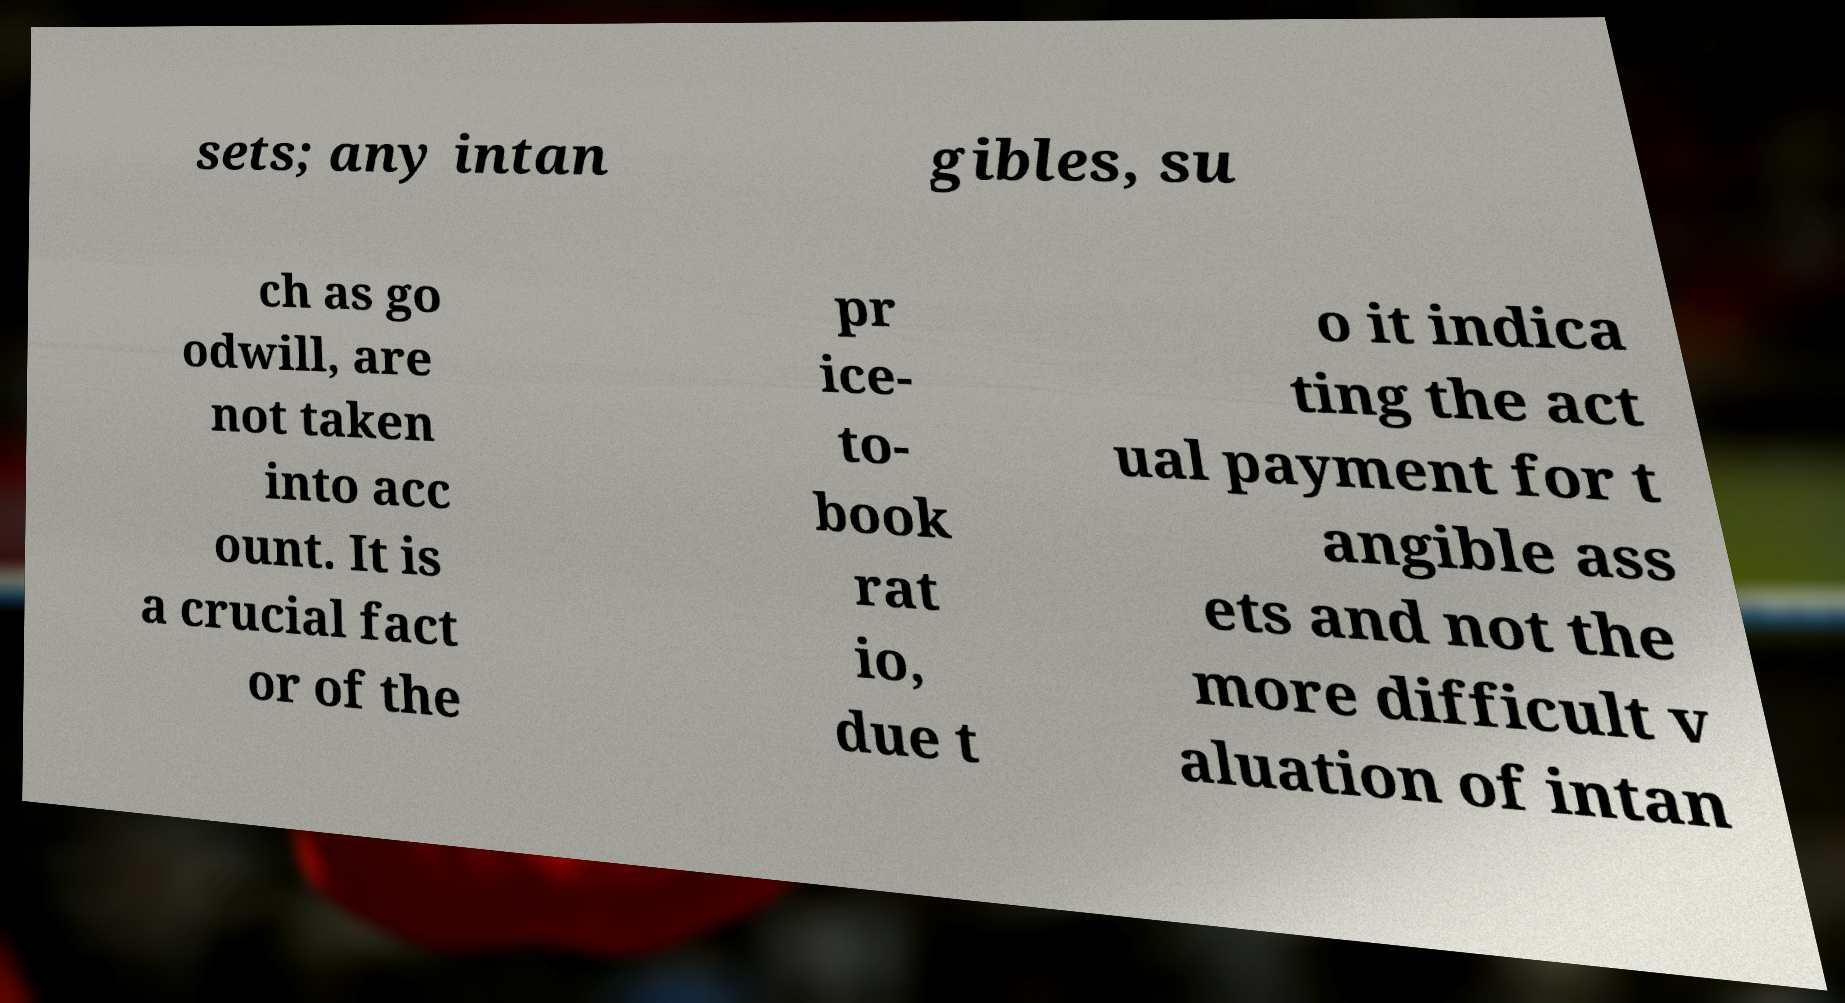Can you read and provide the text displayed in the image?This photo seems to have some interesting text. Can you extract and type it out for me? sets; any intan gibles, su ch as go odwill, are not taken into acc ount. It is a crucial fact or of the pr ice- to- book rat io, due t o it indica ting the act ual payment for t angible ass ets and not the more difficult v aluation of intan 